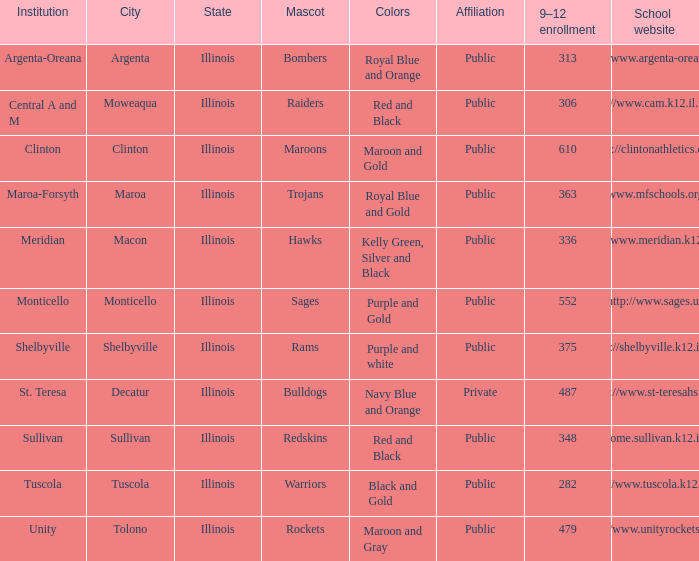What location has 363 students enrolled in the 9th to 12th grades? Maroa, Illinois. 